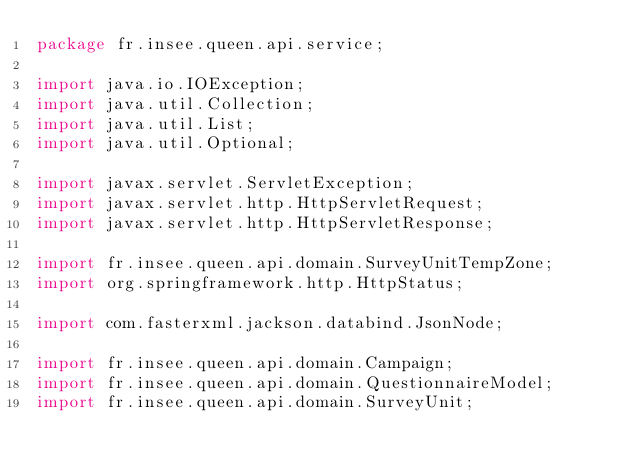<code> <loc_0><loc_0><loc_500><loc_500><_Java_>package fr.insee.queen.api.service;

import java.io.IOException;
import java.util.Collection;
import java.util.List;
import java.util.Optional;

import javax.servlet.ServletException;
import javax.servlet.http.HttpServletRequest;
import javax.servlet.http.HttpServletResponse;

import fr.insee.queen.api.domain.SurveyUnitTempZone;
import org.springframework.http.HttpStatus;

import com.fasterxml.jackson.databind.JsonNode;

import fr.insee.queen.api.domain.Campaign;
import fr.insee.queen.api.domain.QuestionnaireModel;
import fr.insee.queen.api.domain.SurveyUnit;</code> 